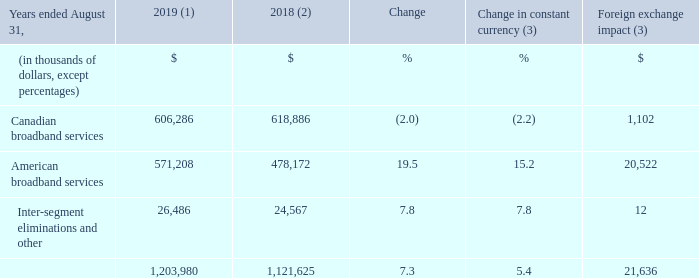OPERATING EXPENSES
(1) Fiscal 2019 average foreign exchange rate used for translation was 1.3255 USD/CDN.
(2) Fiscal 2018 was restated to comply with IFRS 15 and to reflect a change in accounting policy as well as to reclassify results from Cogeco Peer 1 as discontinued
operations. For further details, please consult the "Accounting policies" and "Discontinued operations" sections.
(3) Fiscal 2019 actuals are translated at the average foreign exchange rate of fiscal 2018 which was 1.2773 USD/CDN.
Fiscal 2019 operating expenses increased by 7.3% (5.4% in constant currency) mainly from:
• growth in the American broadband services segment mainly due to the impact of the MetroCast acquisition which was included in operating expenses for only an eight-month period in the prior year combined with higher programming costs, additional headcount to support growth, higher marketing initiatives to drive primary service units growth and the FiberLight acquisition; and
• additional costs in Inter-segment eliminations and other resulting from the timing of corporate projects and initiatives; partly offset by
• lower operating expenses in the Canadian broadband services segment mainly attributable to lower programming costs resulting from a lower level of primary service units and lower compensation expenses resulting from an operational optimization program implemented in the first half of fiscal 2019, partly offset by higher marketing initiatives, additional headcount costs in the first quarter of fiscal 2019 to support the stabilization phase of the new customer management system as well as retroactive costs related to higher rates than expected established by the Copyright Board of Canada.
For further details on the Corporation’s operating expenses, please refer to the "Segmented operating and financial results" section.
What was the exchange rate in 2019? 1.3255 usd/cdn. What was the exchange rate in 2018? 1.2773 usd/cdn. What was the increase in 2019 operating expenses? 7.3%. What was the increase / (decrease) in Canadian broadband services from 2018 to 2019?
Answer scale should be: thousand. 606,286 - 618,886
Answer: -12600. What was the average American broadband services between 2018 and 2019?
Answer scale should be: thousand. (571,208 + 478,172) / 2
Answer: 524690. What was the increase / (decrease) in the Inter-segment eliminations and other from 2018 to 2019?
Answer scale should be: thousand. 26,486 - 24,567
Answer: 1919. 